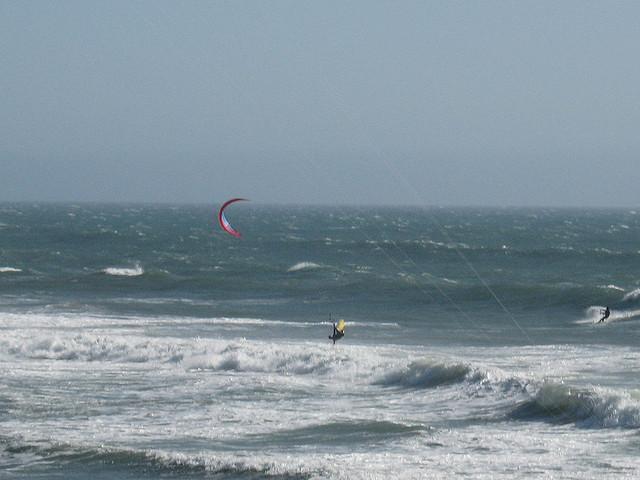How many trains have a number on the front?
Give a very brief answer. 0. 